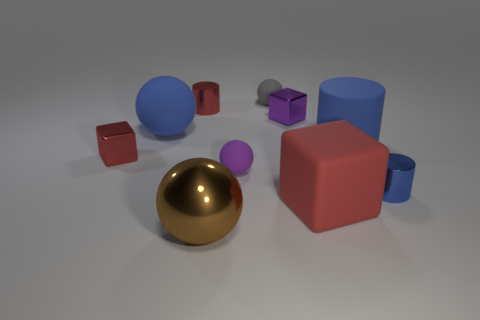How many other things are the same size as the purple cube?
Ensure brevity in your answer.  5. There is another tiny object that is the same shape as the small blue shiny thing; what material is it?
Provide a short and direct response. Metal. What is the size of the purple sphere that is made of the same material as the large red cube?
Your answer should be very brief. Small. There is a matte thing that is the same color as the big rubber cylinder; what is its shape?
Offer a terse response. Sphere. What number of objects are brown matte spheres or tiny objects in front of the gray object?
Ensure brevity in your answer.  5. Are there more tiny cyan rubber objects than small purple rubber things?
Keep it short and to the point. No. There is a blue object left of the small gray ball; what shape is it?
Offer a very short reply. Sphere. How many brown things are the same shape as the gray thing?
Your response must be concise. 1. How big is the metal cylinder left of the tiny rubber object that is behind the large blue cylinder?
Provide a succinct answer. Small. How many blue things are either cubes or metallic cylinders?
Offer a very short reply. 1. 